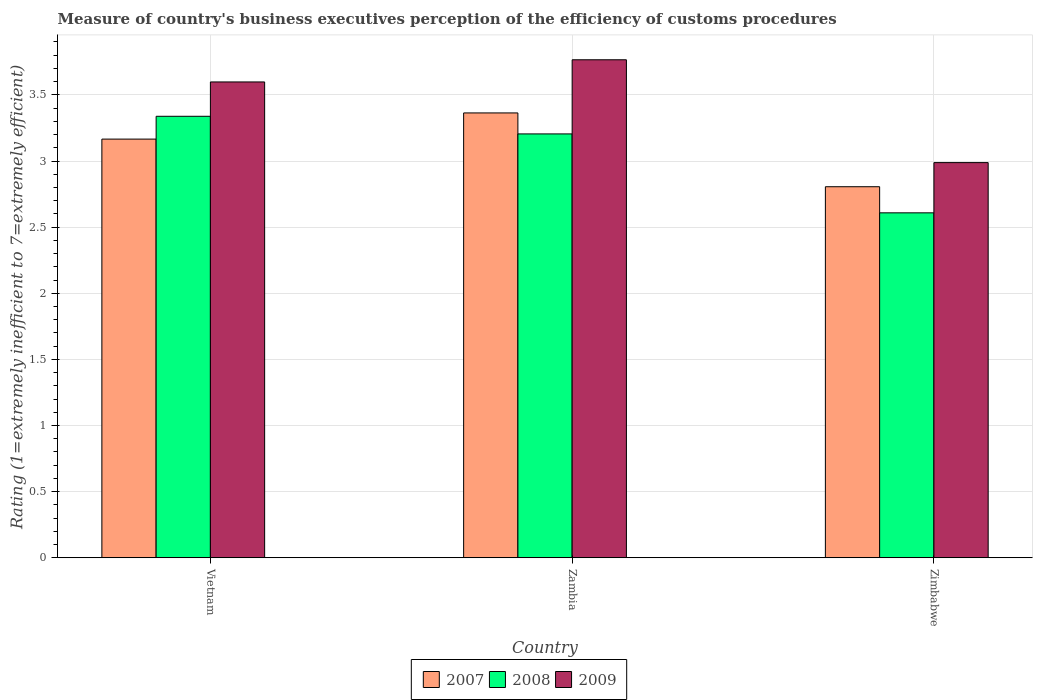How many different coloured bars are there?
Provide a succinct answer. 3. Are the number of bars per tick equal to the number of legend labels?
Offer a terse response. Yes. How many bars are there on the 1st tick from the left?
Offer a very short reply. 3. What is the label of the 3rd group of bars from the left?
Make the answer very short. Zimbabwe. In how many cases, is the number of bars for a given country not equal to the number of legend labels?
Keep it short and to the point. 0. What is the rating of the efficiency of customs procedure in 2009 in Vietnam?
Your response must be concise. 3.6. Across all countries, what is the maximum rating of the efficiency of customs procedure in 2007?
Offer a terse response. 3.36. Across all countries, what is the minimum rating of the efficiency of customs procedure in 2008?
Keep it short and to the point. 2.61. In which country was the rating of the efficiency of customs procedure in 2008 maximum?
Provide a short and direct response. Vietnam. In which country was the rating of the efficiency of customs procedure in 2009 minimum?
Make the answer very short. Zimbabwe. What is the total rating of the efficiency of customs procedure in 2008 in the graph?
Provide a short and direct response. 9.15. What is the difference between the rating of the efficiency of customs procedure in 2007 in Vietnam and that in Zambia?
Ensure brevity in your answer.  -0.2. What is the difference between the rating of the efficiency of customs procedure in 2007 in Zambia and the rating of the efficiency of customs procedure in 2008 in Zimbabwe?
Provide a succinct answer. 0.76. What is the average rating of the efficiency of customs procedure in 2007 per country?
Your response must be concise. 3.11. What is the difference between the rating of the efficiency of customs procedure of/in 2007 and rating of the efficiency of customs procedure of/in 2009 in Zambia?
Make the answer very short. -0.4. What is the ratio of the rating of the efficiency of customs procedure in 2008 in Vietnam to that in Zambia?
Your answer should be very brief. 1.04. What is the difference between the highest and the second highest rating of the efficiency of customs procedure in 2007?
Your answer should be very brief. 0.36. What is the difference between the highest and the lowest rating of the efficiency of customs procedure in 2009?
Provide a succinct answer. 0.78. In how many countries, is the rating of the efficiency of customs procedure in 2009 greater than the average rating of the efficiency of customs procedure in 2009 taken over all countries?
Your response must be concise. 2. Is the sum of the rating of the efficiency of customs procedure in 2007 in Vietnam and Zambia greater than the maximum rating of the efficiency of customs procedure in 2008 across all countries?
Your answer should be compact. Yes. What does the 1st bar from the left in Zimbabwe represents?
Your answer should be compact. 2007. What does the 2nd bar from the right in Zambia represents?
Make the answer very short. 2008. Is it the case that in every country, the sum of the rating of the efficiency of customs procedure in 2007 and rating of the efficiency of customs procedure in 2008 is greater than the rating of the efficiency of customs procedure in 2009?
Ensure brevity in your answer.  Yes. How many bars are there?
Provide a succinct answer. 9. Are the values on the major ticks of Y-axis written in scientific E-notation?
Keep it short and to the point. No. Does the graph contain grids?
Offer a terse response. Yes. Where does the legend appear in the graph?
Provide a succinct answer. Bottom center. How many legend labels are there?
Your answer should be very brief. 3. How are the legend labels stacked?
Your answer should be very brief. Horizontal. What is the title of the graph?
Offer a terse response. Measure of country's business executives perception of the efficiency of customs procedures. Does "1987" appear as one of the legend labels in the graph?
Give a very brief answer. No. What is the label or title of the X-axis?
Ensure brevity in your answer.  Country. What is the label or title of the Y-axis?
Make the answer very short. Rating (1=extremely inefficient to 7=extremely efficient). What is the Rating (1=extremely inefficient to 7=extremely efficient) in 2007 in Vietnam?
Your response must be concise. 3.17. What is the Rating (1=extremely inefficient to 7=extremely efficient) in 2008 in Vietnam?
Your answer should be very brief. 3.34. What is the Rating (1=extremely inefficient to 7=extremely efficient) in 2009 in Vietnam?
Your answer should be very brief. 3.6. What is the Rating (1=extremely inefficient to 7=extremely efficient) in 2007 in Zambia?
Make the answer very short. 3.36. What is the Rating (1=extremely inefficient to 7=extremely efficient) of 2008 in Zambia?
Offer a very short reply. 3.2. What is the Rating (1=extremely inefficient to 7=extremely efficient) of 2009 in Zambia?
Provide a succinct answer. 3.77. What is the Rating (1=extremely inefficient to 7=extremely efficient) in 2007 in Zimbabwe?
Provide a short and direct response. 2.81. What is the Rating (1=extremely inefficient to 7=extremely efficient) in 2008 in Zimbabwe?
Your answer should be very brief. 2.61. What is the Rating (1=extremely inefficient to 7=extremely efficient) of 2009 in Zimbabwe?
Give a very brief answer. 2.99. Across all countries, what is the maximum Rating (1=extremely inefficient to 7=extremely efficient) in 2007?
Keep it short and to the point. 3.36. Across all countries, what is the maximum Rating (1=extremely inefficient to 7=extremely efficient) of 2008?
Your answer should be very brief. 3.34. Across all countries, what is the maximum Rating (1=extremely inefficient to 7=extremely efficient) in 2009?
Provide a succinct answer. 3.77. Across all countries, what is the minimum Rating (1=extremely inefficient to 7=extremely efficient) in 2007?
Provide a short and direct response. 2.81. Across all countries, what is the minimum Rating (1=extremely inefficient to 7=extremely efficient) of 2008?
Your response must be concise. 2.61. Across all countries, what is the minimum Rating (1=extremely inefficient to 7=extremely efficient) in 2009?
Your answer should be compact. 2.99. What is the total Rating (1=extremely inefficient to 7=extremely efficient) of 2007 in the graph?
Give a very brief answer. 9.34. What is the total Rating (1=extremely inefficient to 7=extremely efficient) in 2008 in the graph?
Make the answer very short. 9.15. What is the total Rating (1=extremely inefficient to 7=extremely efficient) of 2009 in the graph?
Make the answer very short. 10.35. What is the difference between the Rating (1=extremely inefficient to 7=extremely efficient) of 2007 in Vietnam and that in Zambia?
Your response must be concise. -0.2. What is the difference between the Rating (1=extremely inefficient to 7=extremely efficient) of 2008 in Vietnam and that in Zambia?
Give a very brief answer. 0.13. What is the difference between the Rating (1=extremely inefficient to 7=extremely efficient) in 2009 in Vietnam and that in Zambia?
Offer a very short reply. -0.17. What is the difference between the Rating (1=extremely inefficient to 7=extremely efficient) of 2007 in Vietnam and that in Zimbabwe?
Your answer should be very brief. 0.36. What is the difference between the Rating (1=extremely inefficient to 7=extremely efficient) of 2008 in Vietnam and that in Zimbabwe?
Offer a very short reply. 0.73. What is the difference between the Rating (1=extremely inefficient to 7=extremely efficient) of 2009 in Vietnam and that in Zimbabwe?
Your response must be concise. 0.61. What is the difference between the Rating (1=extremely inefficient to 7=extremely efficient) of 2007 in Zambia and that in Zimbabwe?
Ensure brevity in your answer.  0.56. What is the difference between the Rating (1=extremely inefficient to 7=extremely efficient) of 2008 in Zambia and that in Zimbabwe?
Make the answer very short. 0.6. What is the difference between the Rating (1=extremely inefficient to 7=extremely efficient) of 2009 in Zambia and that in Zimbabwe?
Ensure brevity in your answer.  0.78. What is the difference between the Rating (1=extremely inefficient to 7=extremely efficient) in 2007 in Vietnam and the Rating (1=extremely inefficient to 7=extremely efficient) in 2008 in Zambia?
Your response must be concise. -0.04. What is the difference between the Rating (1=extremely inefficient to 7=extremely efficient) of 2007 in Vietnam and the Rating (1=extremely inefficient to 7=extremely efficient) of 2009 in Zambia?
Make the answer very short. -0.6. What is the difference between the Rating (1=extremely inefficient to 7=extremely efficient) in 2008 in Vietnam and the Rating (1=extremely inefficient to 7=extremely efficient) in 2009 in Zambia?
Keep it short and to the point. -0.43. What is the difference between the Rating (1=extremely inefficient to 7=extremely efficient) in 2007 in Vietnam and the Rating (1=extremely inefficient to 7=extremely efficient) in 2008 in Zimbabwe?
Your answer should be very brief. 0.56. What is the difference between the Rating (1=extremely inefficient to 7=extremely efficient) of 2007 in Vietnam and the Rating (1=extremely inefficient to 7=extremely efficient) of 2009 in Zimbabwe?
Make the answer very short. 0.18. What is the difference between the Rating (1=extremely inefficient to 7=extremely efficient) in 2008 in Vietnam and the Rating (1=extremely inefficient to 7=extremely efficient) in 2009 in Zimbabwe?
Make the answer very short. 0.35. What is the difference between the Rating (1=extremely inefficient to 7=extremely efficient) in 2007 in Zambia and the Rating (1=extremely inefficient to 7=extremely efficient) in 2008 in Zimbabwe?
Keep it short and to the point. 0.76. What is the difference between the Rating (1=extremely inefficient to 7=extremely efficient) in 2007 in Zambia and the Rating (1=extremely inefficient to 7=extremely efficient) in 2009 in Zimbabwe?
Ensure brevity in your answer.  0.38. What is the difference between the Rating (1=extremely inefficient to 7=extremely efficient) of 2008 in Zambia and the Rating (1=extremely inefficient to 7=extremely efficient) of 2009 in Zimbabwe?
Offer a very short reply. 0.22. What is the average Rating (1=extremely inefficient to 7=extremely efficient) of 2007 per country?
Your answer should be very brief. 3.11. What is the average Rating (1=extremely inefficient to 7=extremely efficient) of 2008 per country?
Your answer should be compact. 3.05. What is the average Rating (1=extremely inefficient to 7=extremely efficient) of 2009 per country?
Ensure brevity in your answer.  3.45. What is the difference between the Rating (1=extremely inefficient to 7=extremely efficient) of 2007 and Rating (1=extremely inefficient to 7=extremely efficient) of 2008 in Vietnam?
Offer a very short reply. -0.17. What is the difference between the Rating (1=extremely inefficient to 7=extremely efficient) of 2007 and Rating (1=extremely inefficient to 7=extremely efficient) of 2009 in Vietnam?
Ensure brevity in your answer.  -0.43. What is the difference between the Rating (1=extremely inefficient to 7=extremely efficient) in 2008 and Rating (1=extremely inefficient to 7=extremely efficient) in 2009 in Vietnam?
Offer a terse response. -0.26. What is the difference between the Rating (1=extremely inefficient to 7=extremely efficient) of 2007 and Rating (1=extremely inefficient to 7=extremely efficient) of 2008 in Zambia?
Offer a terse response. 0.16. What is the difference between the Rating (1=extremely inefficient to 7=extremely efficient) of 2007 and Rating (1=extremely inefficient to 7=extremely efficient) of 2009 in Zambia?
Your response must be concise. -0.4. What is the difference between the Rating (1=extremely inefficient to 7=extremely efficient) in 2008 and Rating (1=extremely inefficient to 7=extremely efficient) in 2009 in Zambia?
Offer a very short reply. -0.56. What is the difference between the Rating (1=extremely inefficient to 7=extremely efficient) of 2007 and Rating (1=extremely inefficient to 7=extremely efficient) of 2008 in Zimbabwe?
Your answer should be compact. 0.2. What is the difference between the Rating (1=extremely inefficient to 7=extremely efficient) of 2007 and Rating (1=extremely inefficient to 7=extremely efficient) of 2009 in Zimbabwe?
Provide a succinct answer. -0.18. What is the difference between the Rating (1=extremely inefficient to 7=extremely efficient) of 2008 and Rating (1=extremely inefficient to 7=extremely efficient) of 2009 in Zimbabwe?
Give a very brief answer. -0.38. What is the ratio of the Rating (1=extremely inefficient to 7=extremely efficient) in 2007 in Vietnam to that in Zambia?
Provide a succinct answer. 0.94. What is the ratio of the Rating (1=extremely inefficient to 7=extremely efficient) of 2008 in Vietnam to that in Zambia?
Ensure brevity in your answer.  1.04. What is the ratio of the Rating (1=extremely inefficient to 7=extremely efficient) in 2009 in Vietnam to that in Zambia?
Keep it short and to the point. 0.96. What is the ratio of the Rating (1=extremely inefficient to 7=extremely efficient) in 2007 in Vietnam to that in Zimbabwe?
Your response must be concise. 1.13. What is the ratio of the Rating (1=extremely inefficient to 7=extremely efficient) in 2008 in Vietnam to that in Zimbabwe?
Give a very brief answer. 1.28. What is the ratio of the Rating (1=extremely inefficient to 7=extremely efficient) of 2009 in Vietnam to that in Zimbabwe?
Your answer should be compact. 1.2. What is the ratio of the Rating (1=extremely inefficient to 7=extremely efficient) in 2007 in Zambia to that in Zimbabwe?
Your answer should be compact. 1.2. What is the ratio of the Rating (1=extremely inefficient to 7=extremely efficient) in 2008 in Zambia to that in Zimbabwe?
Keep it short and to the point. 1.23. What is the ratio of the Rating (1=extremely inefficient to 7=extremely efficient) in 2009 in Zambia to that in Zimbabwe?
Your response must be concise. 1.26. What is the difference between the highest and the second highest Rating (1=extremely inefficient to 7=extremely efficient) in 2007?
Keep it short and to the point. 0.2. What is the difference between the highest and the second highest Rating (1=extremely inefficient to 7=extremely efficient) in 2008?
Keep it short and to the point. 0.13. What is the difference between the highest and the second highest Rating (1=extremely inefficient to 7=extremely efficient) of 2009?
Give a very brief answer. 0.17. What is the difference between the highest and the lowest Rating (1=extremely inefficient to 7=extremely efficient) of 2007?
Make the answer very short. 0.56. What is the difference between the highest and the lowest Rating (1=extremely inefficient to 7=extremely efficient) in 2008?
Provide a succinct answer. 0.73. What is the difference between the highest and the lowest Rating (1=extremely inefficient to 7=extremely efficient) of 2009?
Keep it short and to the point. 0.78. 